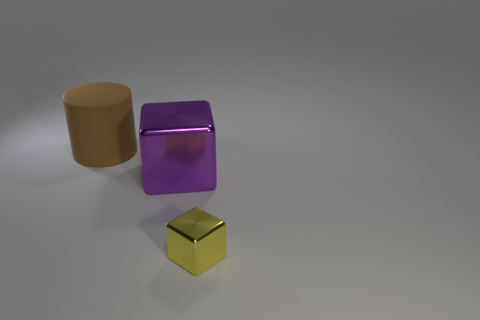Add 2 small yellow cubes. How many objects exist? 5 Subtract all cylinders. How many objects are left? 2 Add 2 brown matte objects. How many brown matte objects exist? 3 Subtract 0 gray spheres. How many objects are left? 3 Subtract all brown matte cylinders. Subtract all metal things. How many objects are left? 0 Add 3 big blocks. How many big blocks are left? 4 